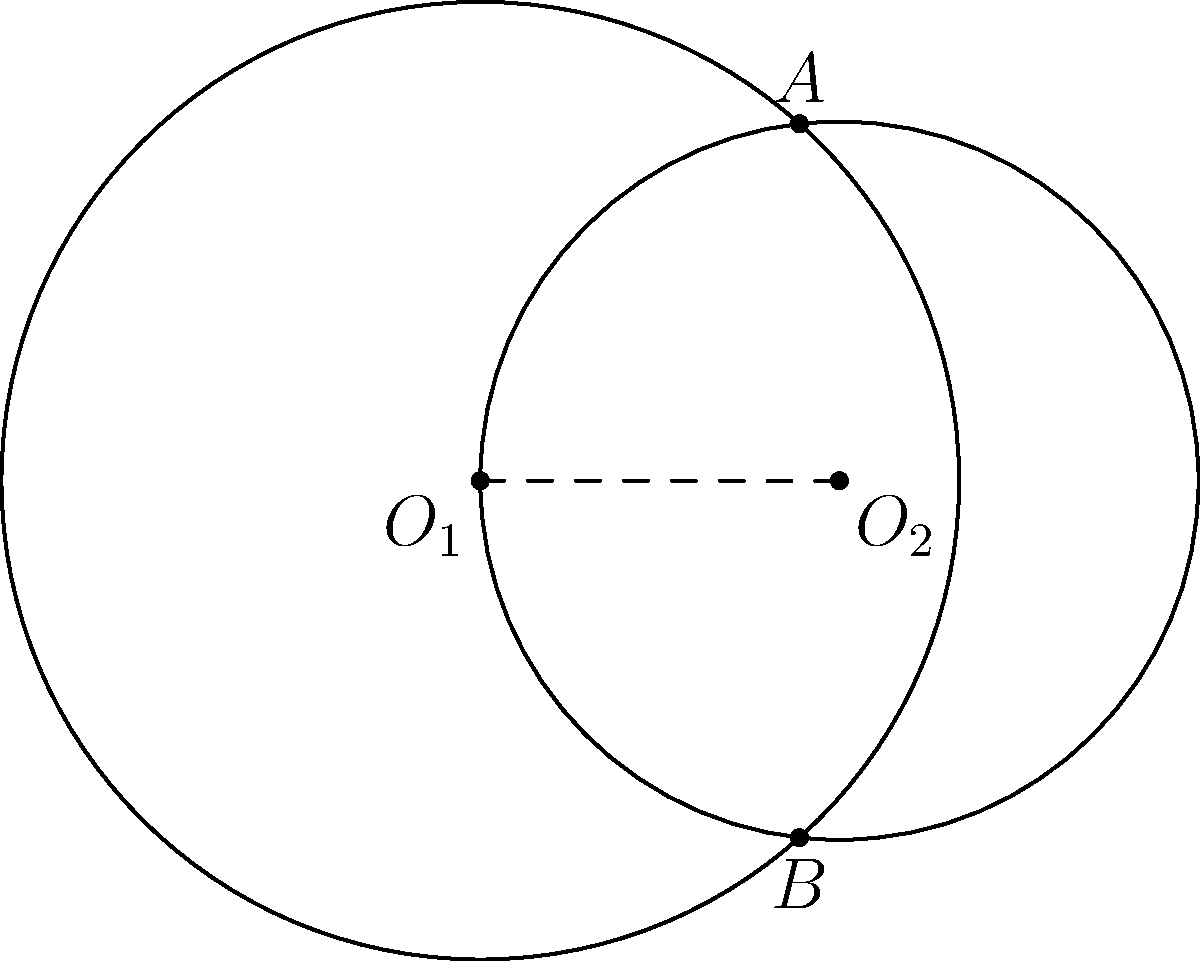In a manufacturing facility, two robotic arms with circular work envelopes are positioned to optimize the production line layout. The centers of these work envelopes are 3 units apart. The first robot has a reach of 4 units, while the second has a reach of 3 units. Calculate the area of the overlapping region where both robots can operate, rounded to two decimal places. How might this information be used to improve the efficiency of the production line in an Industry 4.0 context? To solve this problem, we'll use the formula for the area of the region between two intersecting circles. Let's proceed step-by-step:

1) First, we need to find the distance between the centers of the circles:
   $d = 3$ (given in the problem)

2) The radii of the circles are:
   $r_1 = 4$ and $r_2 = 3$

3) We need to calculate the angle $\theta$ for each circle:
   For circle 1: $\cos(\theta_1/2) = \frac{d^2 + r_1^2 - r_2^2}{2dr_1}$
   $\cos(\theta_1/2) = \frac{3^2 + 4^2 - 3^2}{2 * 3 * 4} = \frac{25}{24}$
   $\theta_1 = 2 * \arccos(\frac{25}{24}) = 0.5149$ radians

   For circle 2: $\cos(\theta_2/2) = \frac{d^2 + r_2^2 - r_1^2}{2dr_2}$
   $\cos(\theta_2/2) = \frac{3^2 + 3^2 - 4^2}{2 * 3 * 3} = \frac{1}{6}$
   $\theta_2 = 2 * \arccos(\frac{1}{6}) = 2.7307$ radians

4) Now we can calculate the area of the overlapping region:
   $A = r_1^2 * (\theta_1 - \sin(\theta_1)) + r_2^2 * (\theta_2 - \sin(\theta_2))$
   $A = 4^2 * (0.5149 - \sin(0.5149)) + 3^2 * (2.7307 - \sin(2.7307))$
   $A = 16 * 0.0168 + 9 * 1.2371$
   $A = 0.2688 + 11.1339$
   $A = 11.4027$

5) Rounding to two decimal places: $A \approx 11.40$ square units

In an Industry 4.0 context, this information could be used to optimize the placement of robots and design of work cells. Understanding the overlapping work envelope allows for better coordination between robots, potentially increasing productivity and reducing downtime. It also helps in planning the positioning of shared resources or workpieces that both robots need to access, enhancing the overall efficiency of the production line.
Answer: 11.40 square units 